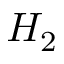Convert formula to latex. <formula><loc_0><loc_0><loc_500><loc_500>H _ { 2 }</formula> 